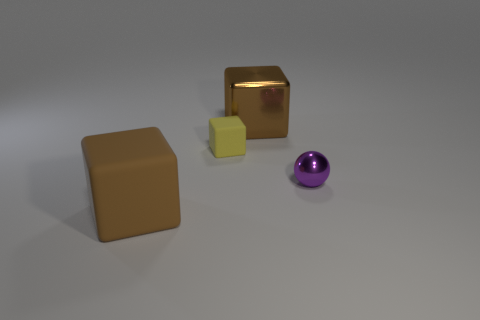Subtract all purple cubes. Subtract all blue cylinders. How many cubes are left? 3 Add 2 big rubber cubes. How many objects exist? 6 Subtract all balls. How many objects are left? 3 Subtract all shiny cubes. Subtract all purple spheres. How many objects are left? 2 Add 2 metal cubes. How many metal cubes are left? 3 Add 3 purple objects. How many purple objects exist? 4 Subtract 1 brown cubes. How many objects are left? 3 